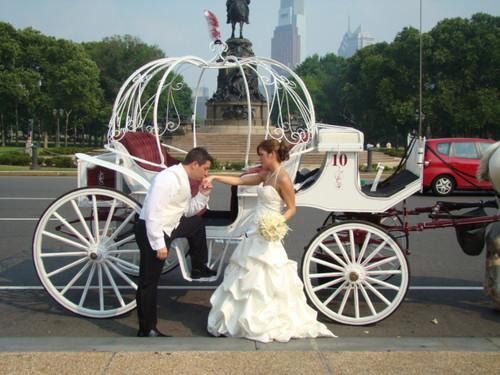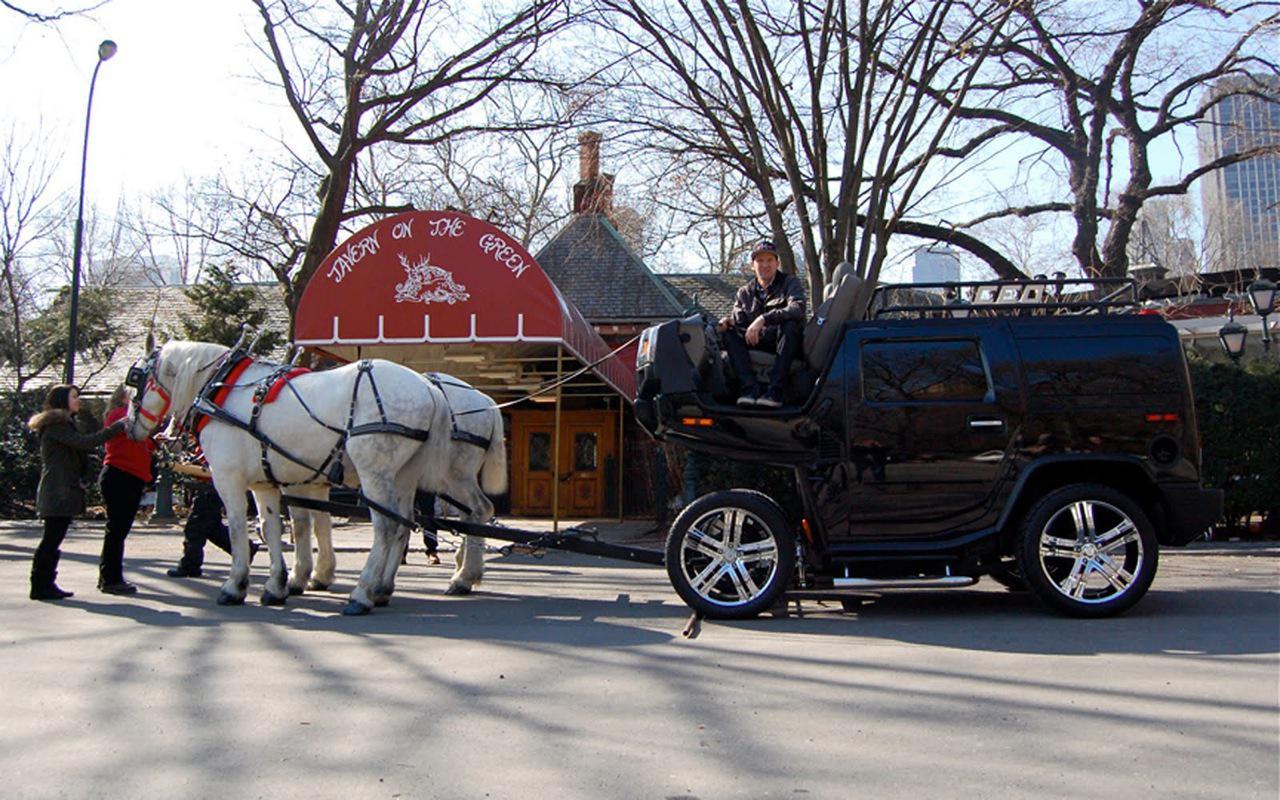The first image is the image on the left, the second image is the image on the right. Assess this claim about the two images: "The horse-drawn cart on the right side is located in a rural setting.". Correct or not? Answer yes or no. No. 